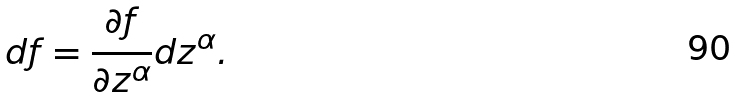<formula> <loc_0><loc_0><loc_500><loc_500>d f = \frac { \partial f } { \partial z ^ { \alpha } } d z ^ { \alpha } .</formula> 